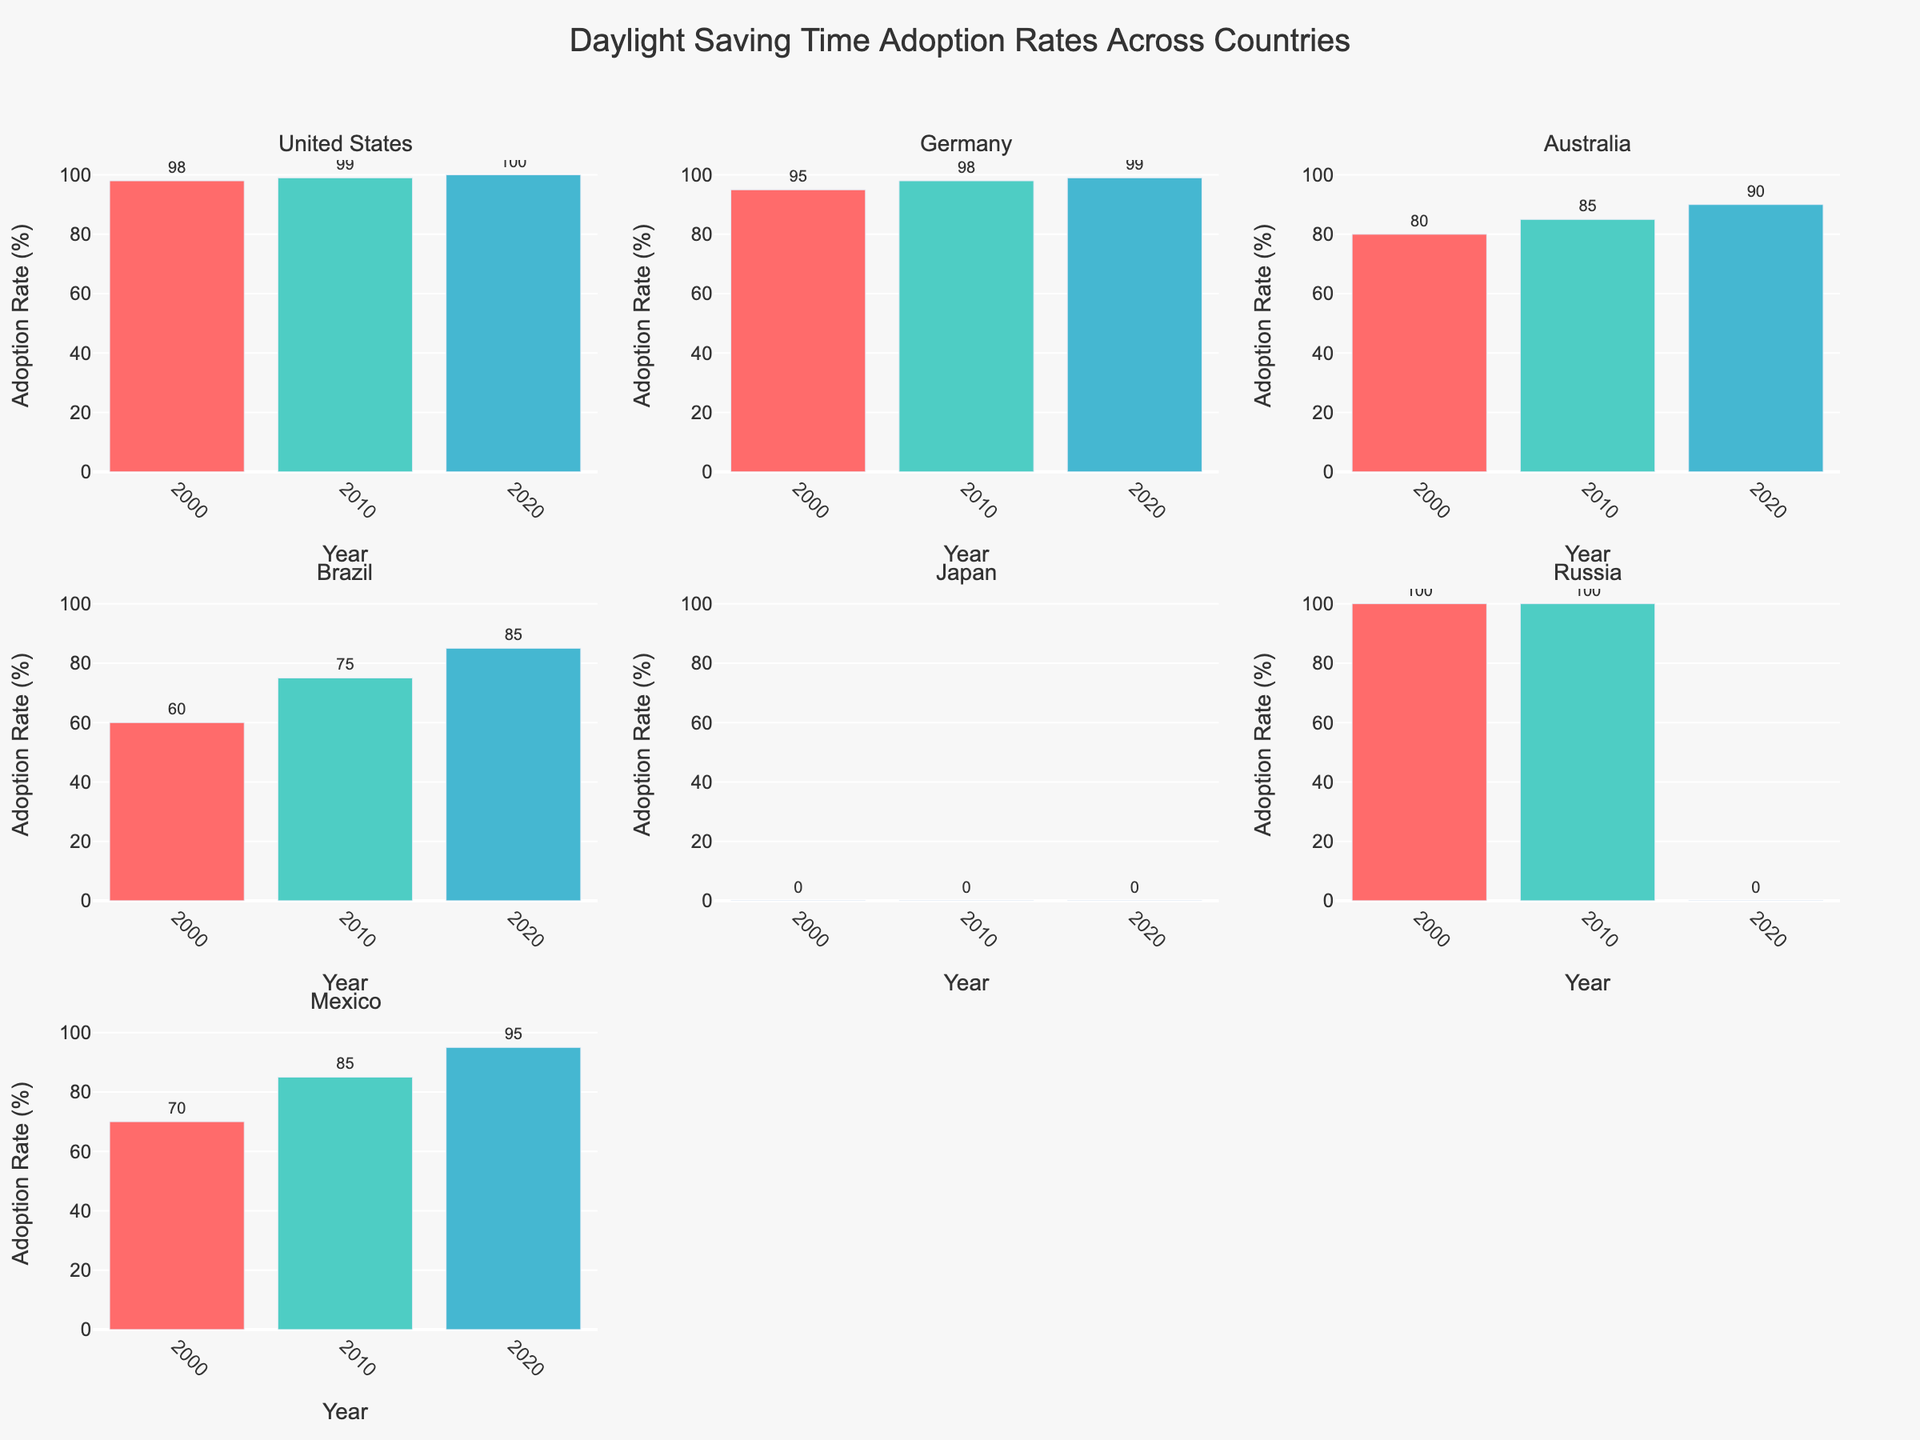What is the title of the figure? The title of the figure is displayed prominently at the top. It reads "Daylight Saving Time Adoption Rates Across Countries".
Answer: Daylight Saving Time Adoption Rates Across Countries What is the adoption rate for Australia in 2020? The adoption rate for Australia in 2020 can be found in the subplot for Australia. Look at the bar labeled '2020' in this subplot.
Answer: 90 How has the adoption rate changed in the United States from 2000 to 2020? In the United States subplot, identify the bars for the years 2000 and 2020. The height of the bars shows the adoption rates, indicating an increase from 98% to 100%.
Answer: Increased Which country had a 0% adoption rate in 2020? Look at the bar heights for the year 2020 across all the subplots. Russia and Japan both have bars indicating 0% adoption for 2020.
Answer: Japan and Russia By how much did the adoption rate in Brazil increase from 2000 to 2010? Look at Brazil's subplot and identify the bars for the years 2000 and 2010. The adoption rate increases from 60% to 75%, so the difference is 15%.
Answer: 15% Compare the adoption rate trend in Germany and Mexico from 2000 to 2020. In the subplots for Germany and Mexico, observe the changes in bar heights from 2000 to 2020. Both countries show an increasing trend, with Germany rising from 95% to 99%, and Mexico from 70% to 95%.
Answer: Both increased What is the rate for the country with the highest adoption rate in 2000? Look at the bars for the year 2000 in all subplots. Russia has the highest adoption rate with a bar at 100%.
Answer: 100% Which countries show a continuous increase in adoption rates from 2000 to 2020? Observe all subplots and track the bar heights from 2000 to 2020. The United States, Germany, Australia, Brazil, and Mexico show continuous increases.
Answer: United States, Germany, Australia, Brazil, and Mexico Why is Russia's adoption rate 0% in 2020? Unlike other questions, this requires domain knowledge about changes in Russia's policy towards daylight saving time in 2011.
Answer: Policy change 